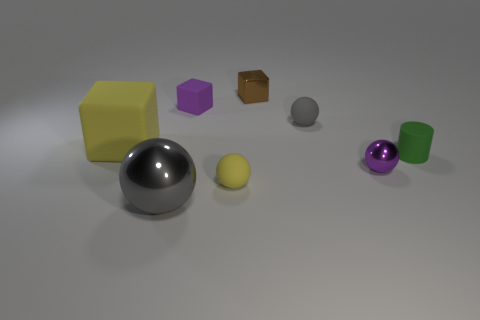Do the big matte cube and the rubber cylinder have the same color?
Offer a terse response. No. The brown metal block has what size?
Provide a succinct answer. Small. What number of other things are there of the same color as the large rubber thing?
Your answer should be very brief. 1. Are the gray sphere left of the gray rubber thing and the brown block made of the same material?
Provide a succinct answer. Yes. Is the number of tiny metal cubes that are in front of the gray rubber object less than the number of small purple things right of the small green thing?
Keep it short and to the point. No. How many other things are the same material as the purple ball?
Give a very brief answer. 2. There is a block that is the same size as the gray metallic sphere; what is its material?
Provide a short and direct response. Rubber. Are there fewer purple things to the left of the small green thing than big yellow cubes?
Give a very brief answer. No. There is a yellow object that is behind the tiny rubber thing in front of the purple object to the right of the small yellow sphere; what is its shape?
Offer a very short reply. Cube. There is a metallic object that is behind the tiny green matte object; what is its size?
Provide a short and direct response. Small. 